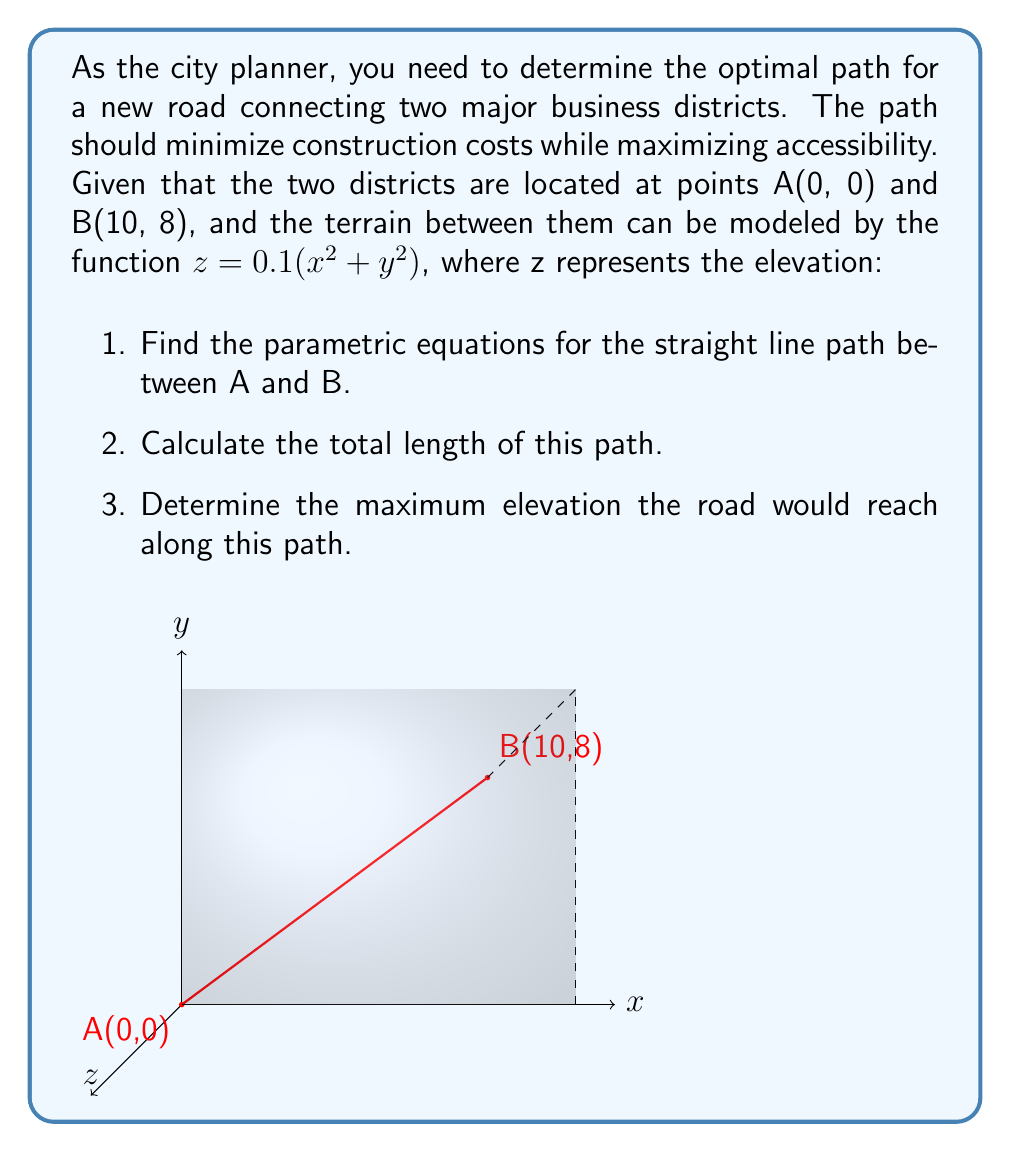Can you answer this question? Let's approach this problem step-by-step:

1. Parametric equations for the straight line path:
   We can use the parameter $t$ where $0 \leq t \leq 1$ to represent the straight line from A to B.
   
   $x = x_A + t(x_B - x_A) = 0 + t(10 - 0) = 10t$
   $y = y_A + t(y_B - y_A) = 0 + t(8 - 0) = 8t$
   
   Therefore, the parametric equations are:
   $$x = 10t$$
   $$y = 8t$$
   $$0 \leq t \leq 1$$

2. Total length of the path:
   We can use the distance formula in 2D:
   $$L = \sqrt{(x_B - x_A)^2 + (y_B - y_A)^2}$$
   $$L = \sqrt{(10 - 0)^2 + (8 - 0)^2} = \sqrt{100 + 64} = \sqrt{164} \approx 12.81$$

3. Maximum elevation:
   The elevation is given by $z = 0.1(x^2 + y^2)$
   Substituting our parametric equations:
   $$z = 0.1((10t)^2 + (8t)^2) = 0.1(100t^2 + 64t^2) = 16.4t^2$$
   
   The maximum elevation will occur at the endpoint B where $t = 1$:
   $$z_{max} = 16.4(1)^2 = 16.4$$

Therefore, the maximum elevation the road would reach is 16.4 units.
Answer: 1. $x = 10t$, $y = 8t$, $0 \leq t \leq 1$
2. $\sqrt{164} \approx 12.81$ units
3. 16.4 units 